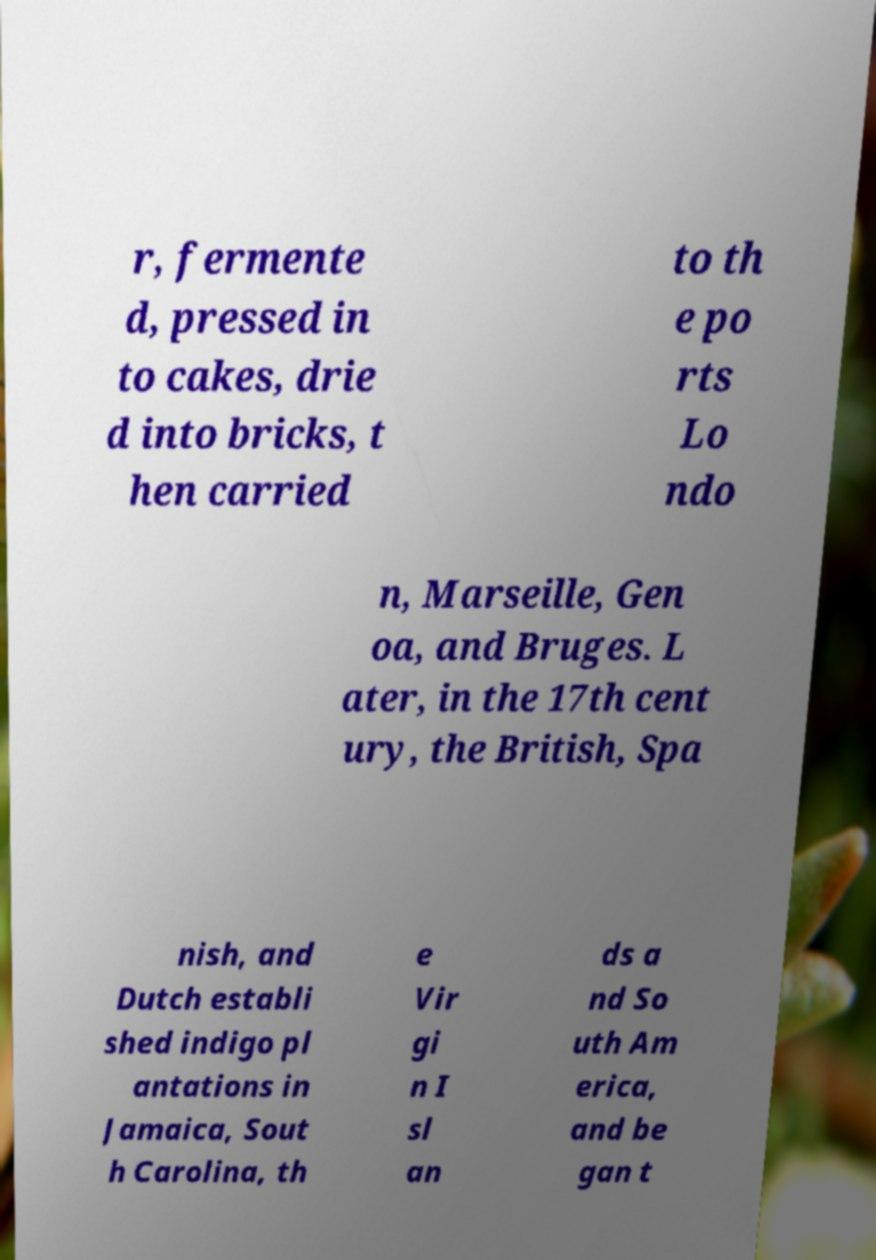Could you extract and type out the text from this image? r, fermente d, pressed in to cakes, drie d into bricks, t hen carried to th e po rts Lo ndo n, Marseille, Gen oa, and Bruges. L ater, in the 17th cent ury, the British, Spa nish, and Dutch establi shed indigo pl antations in Jamaica, Sout h Carolina, th e Vir gi n I sl an ds a nd So uth Am erica, and be gan t 